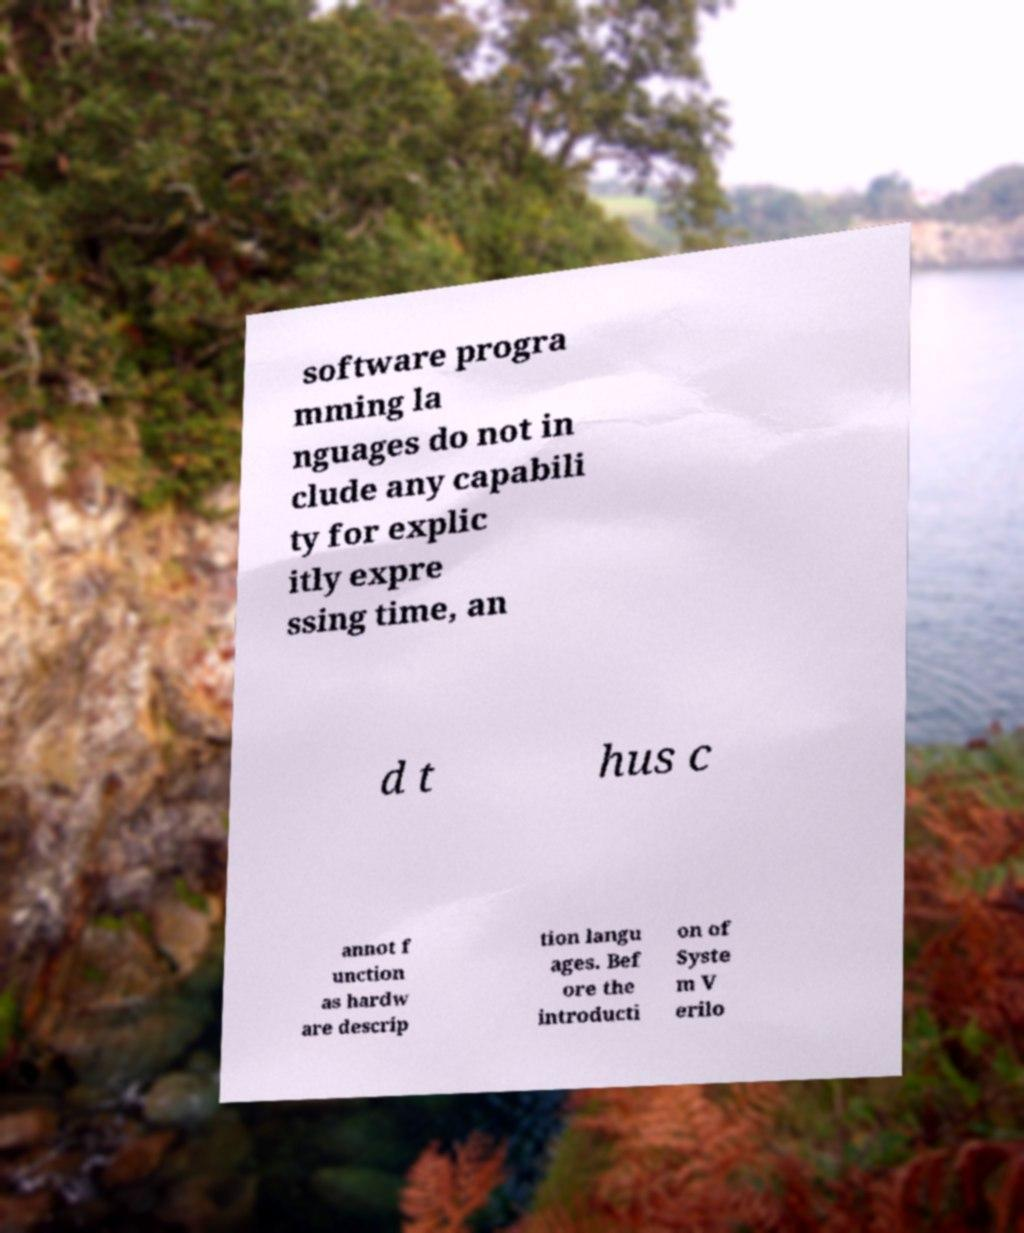For documentation purposes, I need the text within this image transcribed. Could you provide that? software progra mming la nguages do not in clude any capabili ty for explic itly expre ssing time, an d t hus c annot f unction as hardw are descrip tion langu ages. Bef ore the introducti on of Syste m V erilo 